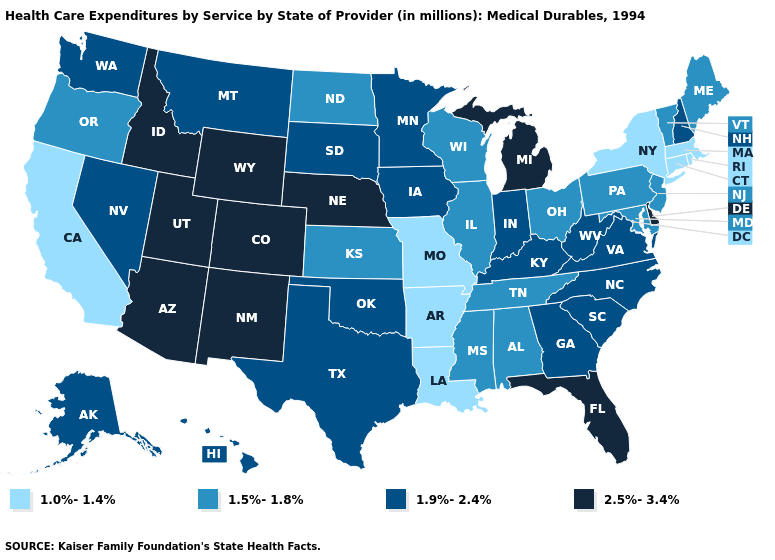Does Kansas have a lower value than Colorado?
Short answer required. Yes. Among the states that border Michigan , does Ohio have the highest value?
Give a very brief answer. No. Name the states that have a value in the range 1.0%-1.4%?
Concise answer only. Arkansas, California, Connecticut, Louisiana, Massachusetts, Missouri, New York, Rhode Island. What is the highest value in states that border Utah?
Quick response, please. 2.5%-3.4%. Among the states that border Louisiana , which have the highest value?
Write a very short answer. Texas. Is the legend a continuous bar?
Concise answer only. No. Is the legend a continuous bar?
Keep it brief. No. What is the highest value in states that border Idaho?
Give a very brief answer. 2.5%-3.4%. What is the highest value in the USA?
Keep it brief. 2.5%-3.4%. What is the value of Connecticut?
Concise answer only. 1.0%-1.4%. Does New Jersey have the lowest value in the Northeast?
Short answer required. No. What is the value of Kansas?
Keep it brief. 1.5%-1.8%. What is the value of South Carolina?
Quick response, please. 1.9%-2.4%. What is the lowest value in states that border Florida?
Give a very brief answer. 1.5%-1.8%. What is the value of Virginia?
Short answer required. 1.9%-2.4%. 